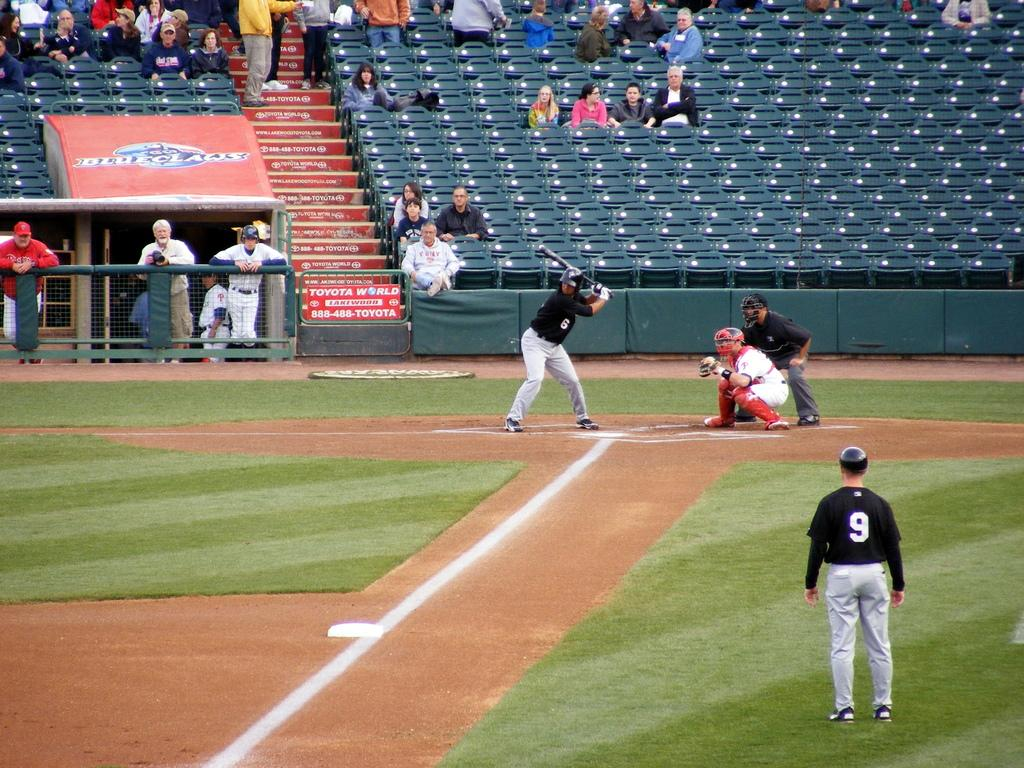<image>
Render a clear and concise summary of the photo. Men are playing baseball and a sign advertising Toyota World is on the fence. 